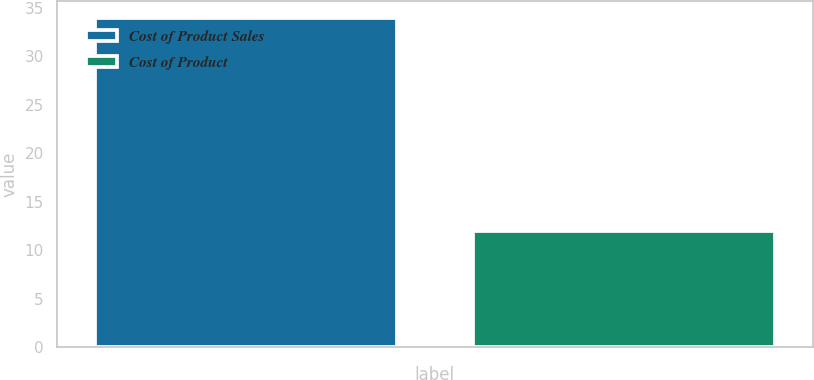Convert chart. <chart><loc_0><loc_0><loc_500><loc_500><bar_chart><fcel>Cost of Product Sales<fcel>Cost of Product<nl><fcel>34<fcel>12<nl></chart> 